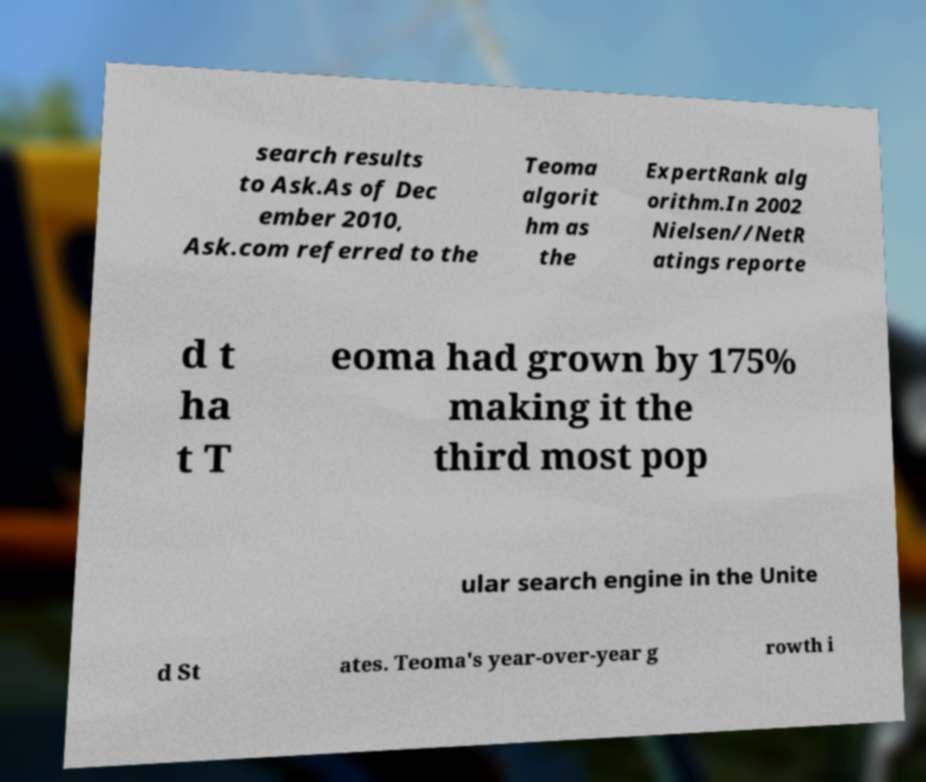Could you extract and type out the text from this image? search results to Ask.As of Dec ember 2010, Ask.com referred to the Teoma algorit hm as the ExpertRank alg orithm.In 2002 Nielsen//NetR atings reporte d t ha t T eoma had grown by 175% making it the third most pop ular search engine in the Unite d St ates. Teoma's year-over-year g rowth i 